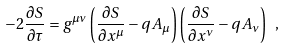Convert formula to latex. <formula><loc_0><loc_0><loc_500><loc_500>- 2 \frac { \partial S } { \partial \tau } = g ^ { \mu \nu } \left ( \frac { \partial S } { \partial x ^ { \mu } } - q A _ { \mu } \right ) \left ( \frac { \partial S } { \partial x ^ { \nu } } - q A _ { \nu } \right ) \ ,</formula> 